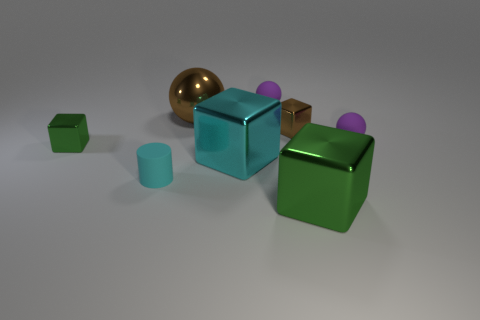What material is the tiny green block on the left side of the green metallic thing in front of the green shiny block behind the large green metal object?
Offer a terse response. Metal. Are the large brown ball right of the tiny cyan rubber cylinder and the tiny object behind the brown shiny sphere made of the same material?
Provide a succinct answer. No. What size is the thing that is behind the large green object and in front of the big cyan shiny block?
Provide a succinct answer. Small. There is a brown thing that is the same size as the cyan metallic thing; what is its material?
Your response must be concise. Metal. There is a small thing that is on the right side of the tiny shiny object that is right of the tiny green cube; how many matte balls are behind it?
Offer a terse response. 1. There is a block that is in front of the small cyan cylinder; does it have the same color as the rubber ball on the left side of the large green block?
Keep it short and to the point. No. What color is the thing that is both behind the small green metal block and to the right of the tiny brown thing?
Offer a terse response. Purple. What number of blocks have the same size as the brown shiny sphere?
Keep it short and to the point. 2. What is the shape of the tiny metallic object on the left side of the cyan object in front of the cyan shiny cube?
Offer a terse response. Cube. The small purple thing that is right of the green shiny block in front of the cyan thing right of the shiny sphere is what shape?
Provide a succinct answer. Sphere. 